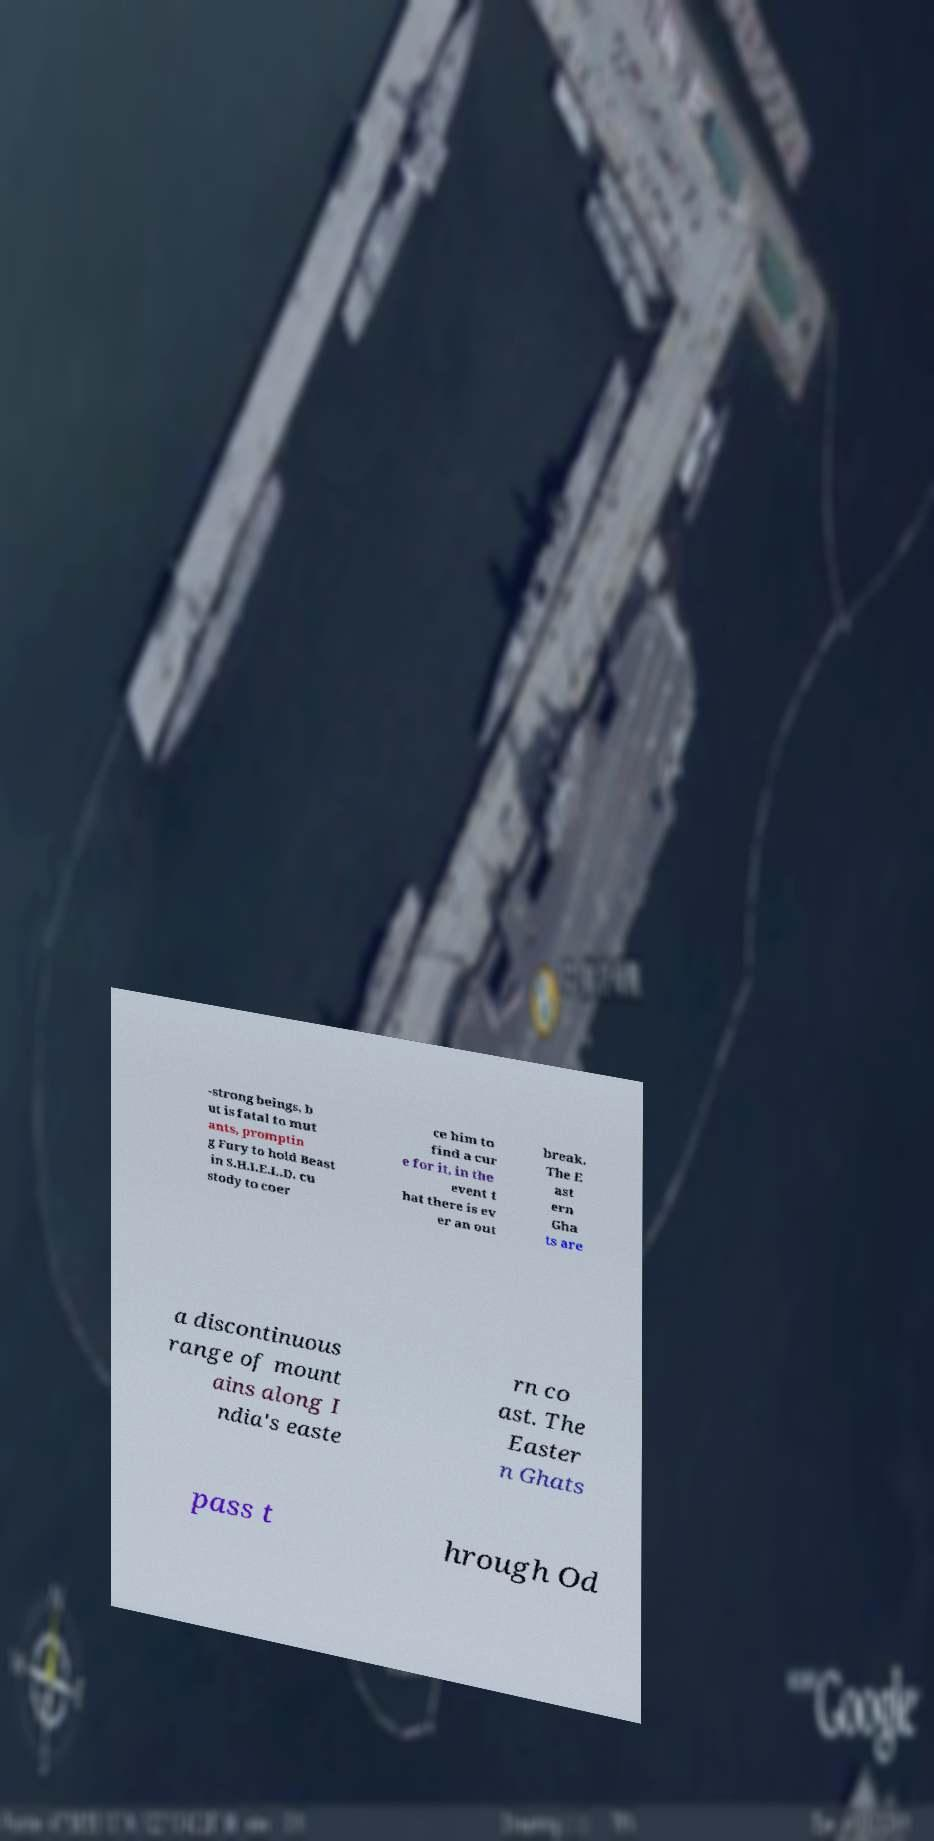Could you assist in decoding the text presented in this image and type it out clearly? -strong beings, b ut is fatal to mut ants, promptin g Fury to hold Beast in S.H.I.E.L.D. cu stody to coer ce him to find a cur e for it, in the event t hat there is ev er an out break. The E ast ern Gha ts are a discontinuous range of mount ains along I ndia's easte rn co ast. The Easter n Ghats pass t hrough Od 